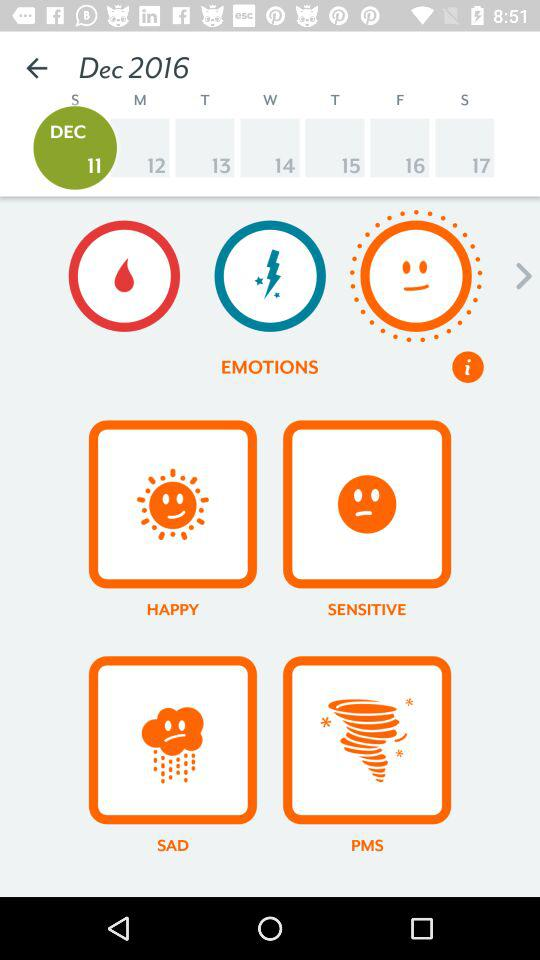What is the selected date? The selected date is Sunday, December 11, 2016. 